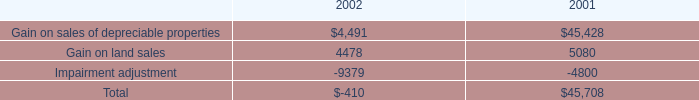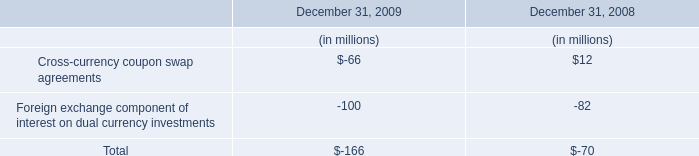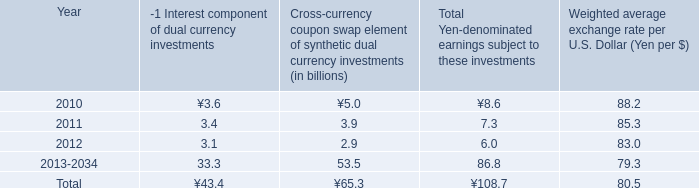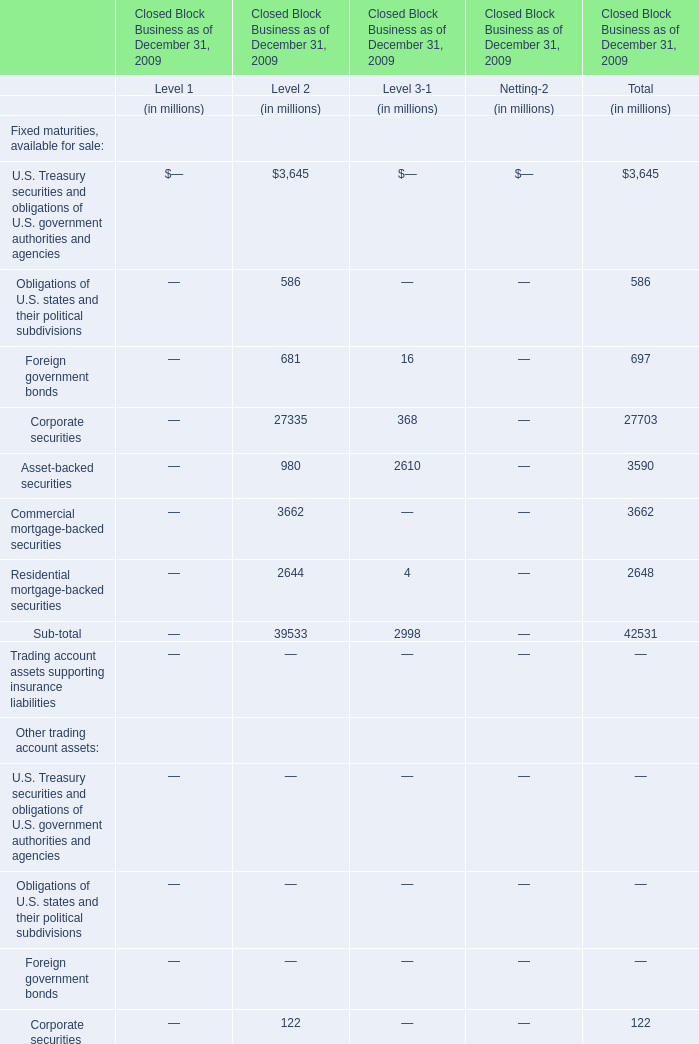What is the ratio of Short-term investments for Level 1 to the total in 2009? 
Computations: (1017 / 4092)
Answer: 0.24853. 